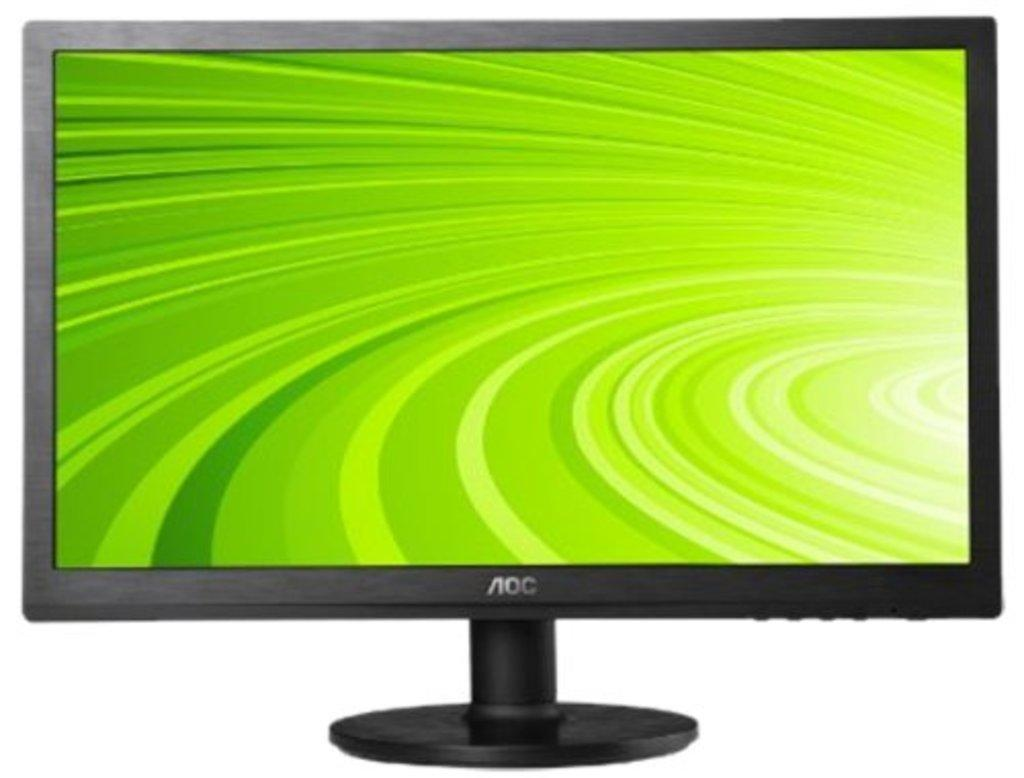Provide a one-sentence caption for the provided image. A computer that says AOC and features a green striped background. 